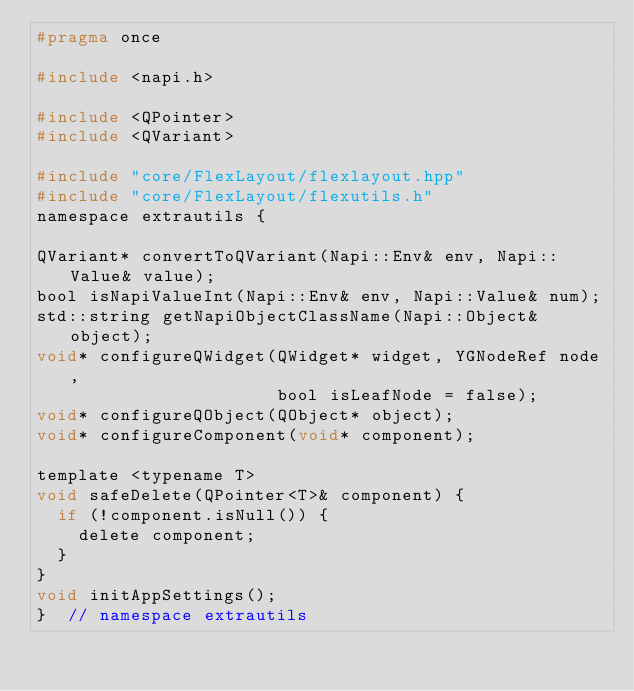Convert code to text. <code><loc_0><loc_0><loc_500><loc_500><_C_>#pragma once

#include <napi.h>

#include <QPointer>
#include <QVariant>

#include "core/FlexLayout/flexlayout.hpp"
#include "core/FlexLayout/flexutils.h"
namespace extrautils {

QVariant* convertToQVariant(Napi::Env& env, Napi::Value& value);
bool isNapiValueInt(Napi::Env& env, Napi::Value& num);
std::string getNapiObjectClassName(Napi::Object& object);
void* configureQWidget(QWidget* widget, YGNodeRef node,
                       bool isLeafNode = false);
void* configureQObject(QObject* object);
void* configureComponent(void* component);

template <typename T>
void safeDelete(QPointer<T>& component) {
  if (!component.isNull()) {
    delete component;
  }
}
void initAppSettings();
}  // namespace extrautils
</code> 